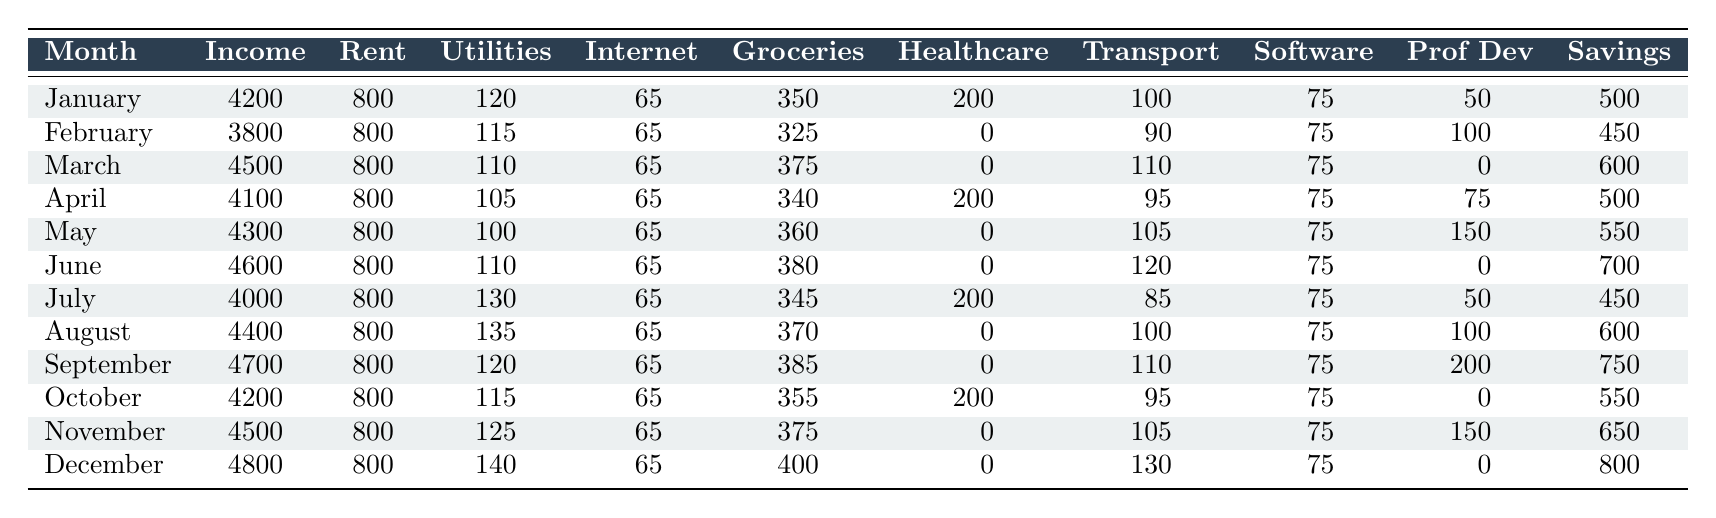What was the total income for the freelancer in December? To find the total income for December, we look at the "Income" column specifically for the row that corresponds to December. The value listed is 4800.
Answer: 4800 What was the highest expense on utilities for any month in 2022? We analyze the "Utilities" column and find the maximum value, which is 140 in December.
Answer: 140 What was the average income for the freelancer across all twelve months? To calculate the average income, we add all the monthly incomes together (4200 + 3800 + 4500 + 4100 + 4300 + 4600 + 4000 + 4400 + 4700 + 4200 + 4500 + 4800 = 53,100) and divide by 12 (53,100 / 12 = 4,425).
Answer: 4425 Did the freelancer ever spend more than $200 on healthcare in a month? By looking at the "Healthcare" column, we can see each month's healthcare costs. The only months with expenses are January ($200), April ($200), and all other months have $0. Therefore, the answer is no, the freelancer never spent more than $200.
Answer: No In which month did the freelancer have the highest savings, and what was the amount? We look at the "Savings" column and identify the highest value, which is 800 in December. Therefore, the month with the highest savings is December, with an amount of 800.
Answer: December, 800 What was the total transportation cost for the freelancer during the second half of the year (July to December)? We sum the transportation costs from July (85), August (100), September (110), October (95), November (105), and December (130). The total is 85 + 100 + 110 + 95 + 105 + 130 = 625.
Answer: 625 Was the income in February lower than that in June? The income for February is 3800 and for June it's 4600. Since 3800 is less than 4600, the answer is yes.
Answer: Yes What is the difference between the total income and total expenses for the freelancer in March? For March, the total income is 4500. To find total expenses, we sum all the expenses: Rent (800) + Utilities (110) + Internet (65) + Groceries (375) + Healthcare (0) + Transportation (110) + Software (75) + Professional Development (0) = 1230. The difference is 4500 - 1230 = 3270.
Answer: 3270 How much did the freelancer spend on professional development from May to November? We sum expenses from May (150), June (0), July (50), August (100), September (200), October (0), and November (150). The total is 150 + 0 + 50 + 100 + 200 + 0 + 150 = 650.
Answer: 650 In which month did the freelancer earn the lowest income, and what was the amount? We review the "Income" column to find the lowest value of 3800 in February. Thus, the freelancer earned the lowest income in February.
Answer: February, 3800 